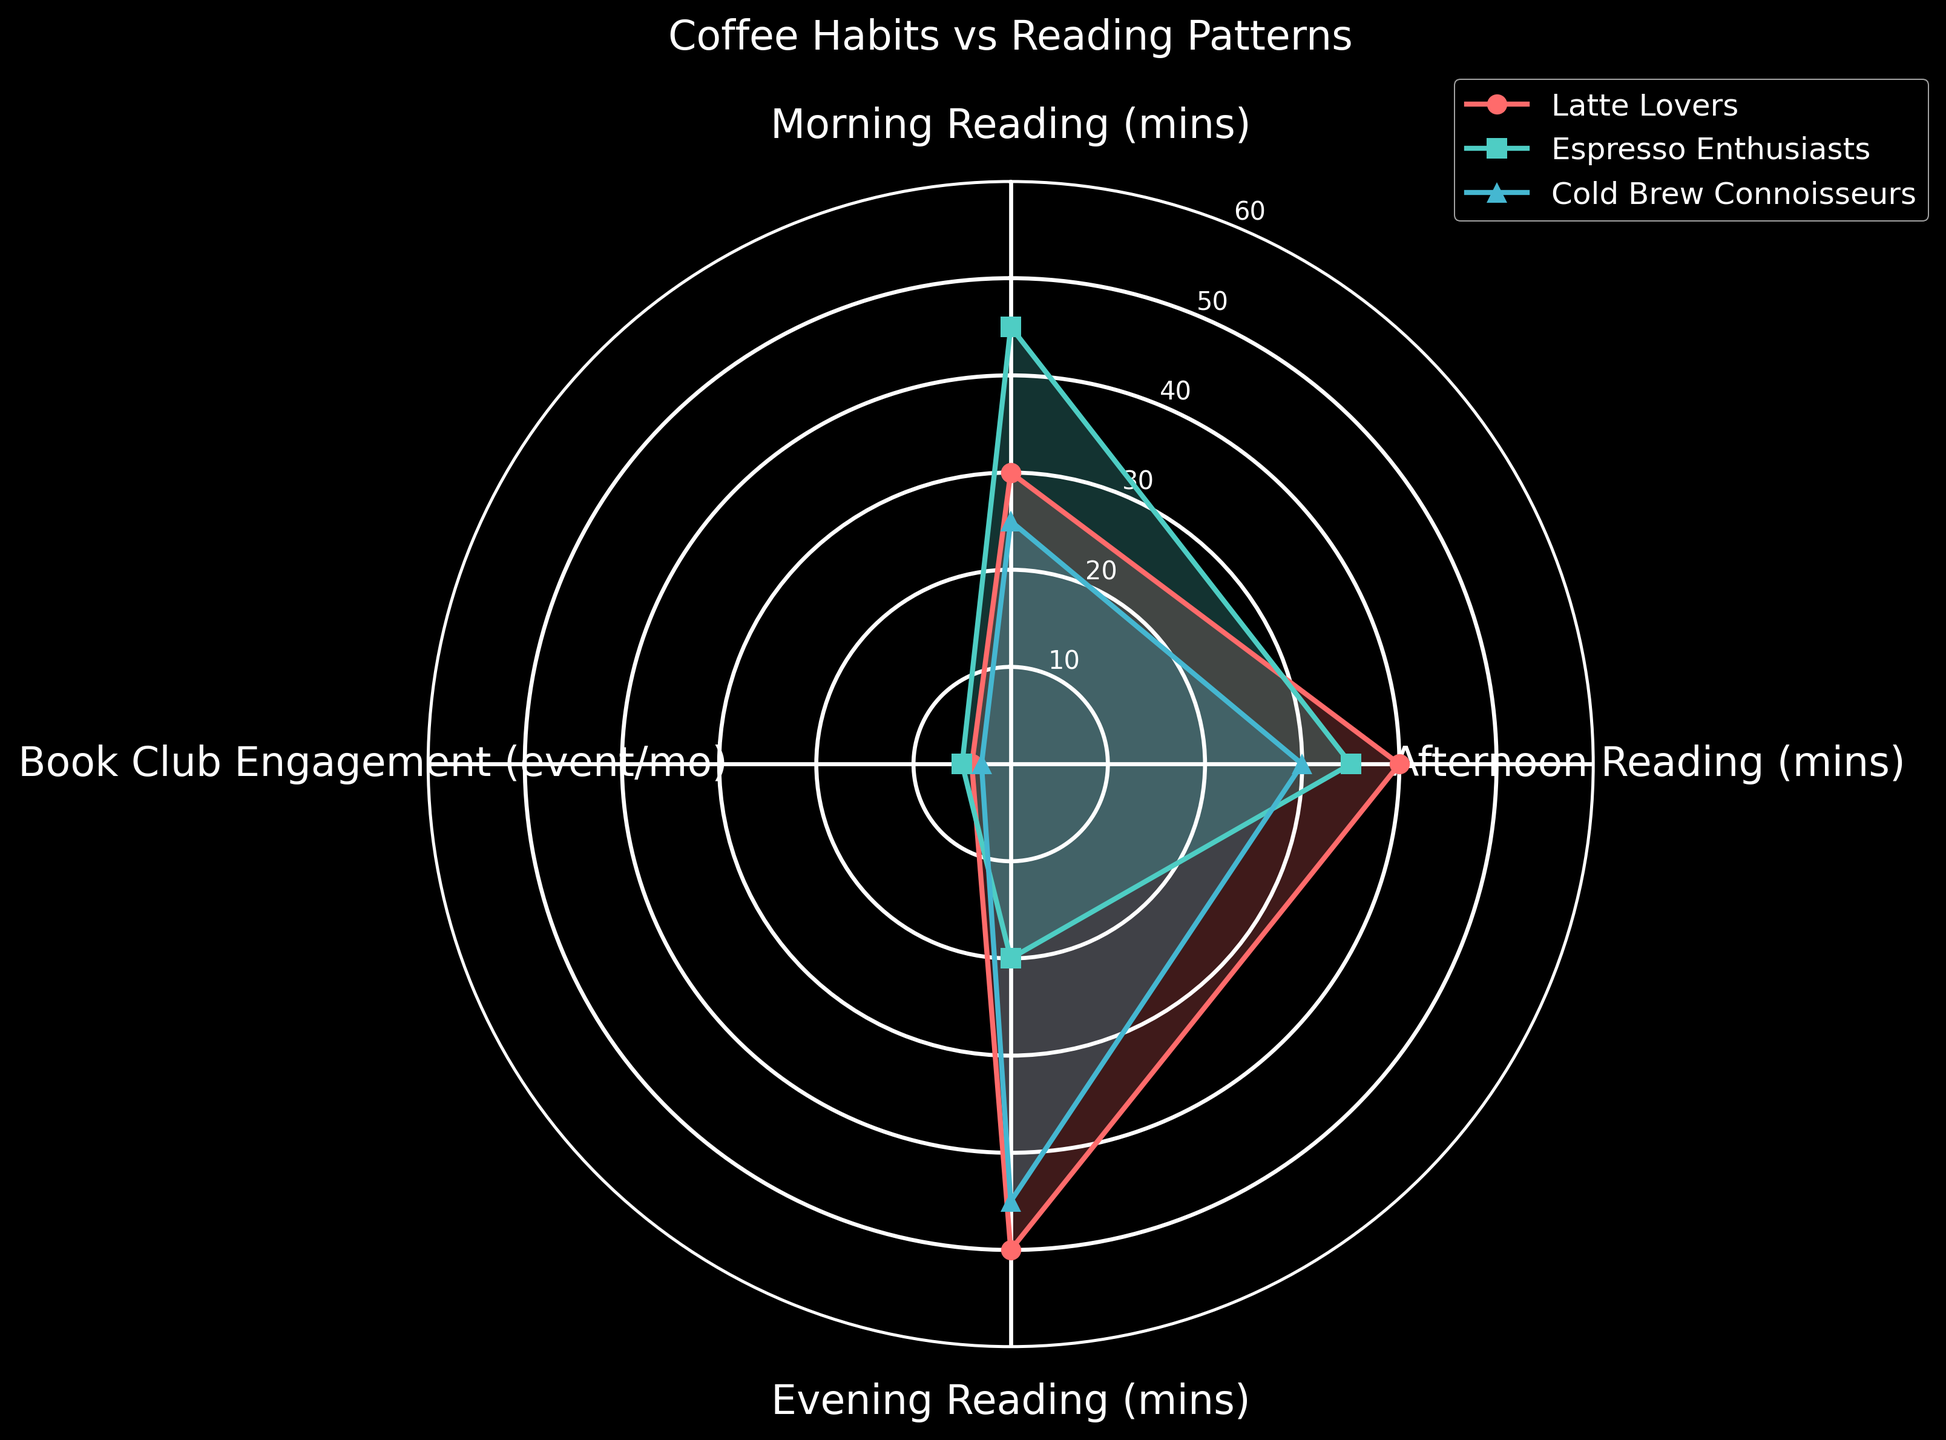Which coffee group reads the most in the morning? To find out which group reads the most in the morning, look at the data points for "Morning Reading (mins)" for each group. The highest value is 45 minutes for Espresso Enthusiasts.
Answer: Espresso Enthusiasts Which coffee group has the highest book club engagement? Look at the "Book Club Engagement (event/mo)" data for each group. The highest value is 5 events per month for Espresso Enthusiasts.
Answer: Espresso Enthusiasts What is the total reading time in the afternoon for all groups combined? Sum the "Afternoon Reading (mins)" values for all groups: 40 (Latte Lovers) + 35 (Espresso Enthusiasts) + 30 (Cold Brew Connoisseurs) = 105 minutes.
Answer: 105 minutes Which coffee group has the least evening reading time? Check the "Evening Reading (mins)" data for each group. The lowest value is 20 minutes for Espresso Enthusiasts.
Answer: Espresso Enthusiasts How does the morning reading time compare between Latte Lovers and Cold Brew Connoisseurs? Compare the values for "Morning Reading (mins)" for Latte Lovers (30 minutes) and Cold Brew Connoisseurs (25 minutes). Latte Lovers read 5 minutes more than Cold Brew Connoisseurs in the morning.
Answer: Latte Lovers read more What's the difference in book club engagement between Latte Lovers and Cold Brew Connoisseurs? Subtract the value for Cold Brew Connoisseurs (3 events) from Latte Lovers (4 events): 4 - 3 = 1 event.
Answer: 1 event Which group has the highest variability in reading times across different times of the day? Compare the range of Morning, Afternoon, and Evening Reading (mins) for each group. Espresso Enthusiasts have the greatest variability (Morning: 45, Afternoon: 35, Evening: 20; range = 25 mins).
Answer: Espresso Enthusiasts What is the average morning reading time across all groups? Sum the "Morning Reading (mins)" values for all groups and divide by the number of groups: (30 + 45 + 25) / 3 = 33.33 minutes.
Answer: 33.33 minutes Which groups have an equal number of events for book club engagement? Compare the "Book Club Engagement (event/mo)" data: None of the groups have equal engagement numbers.
Answer: None Which coffee group reads the least in the afternoon? Look at the "Afternoon Reading (mins)" data for each group. The lowest value is 30 minutes for Cold Brew Connoisseurs.
Answer: Cold Brew Connoisseurs 